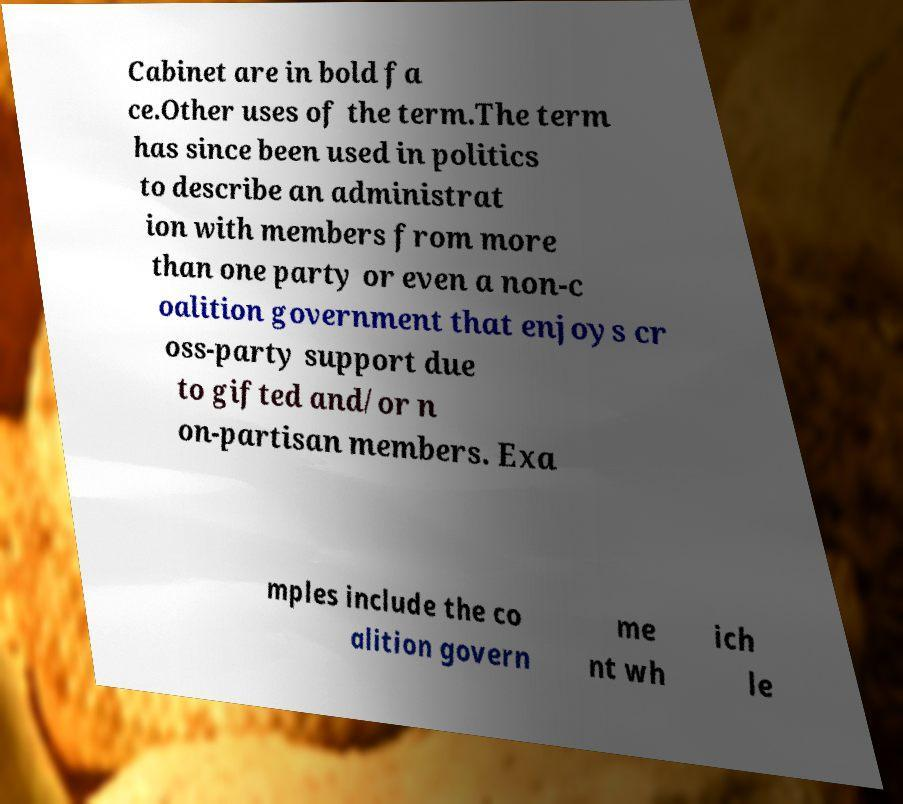Please read and relay the text visible in this image. What does it say? Cabinet are in bold fa ce.Other uses of the term.The term has since been used in politics to describe an administrat ion with members from more than one party or even a non-c oalition government that enjoys cr oss-party support due to gifted and/or n on-partisan members. Exa mples include the co alition govern me nt wh ich le 